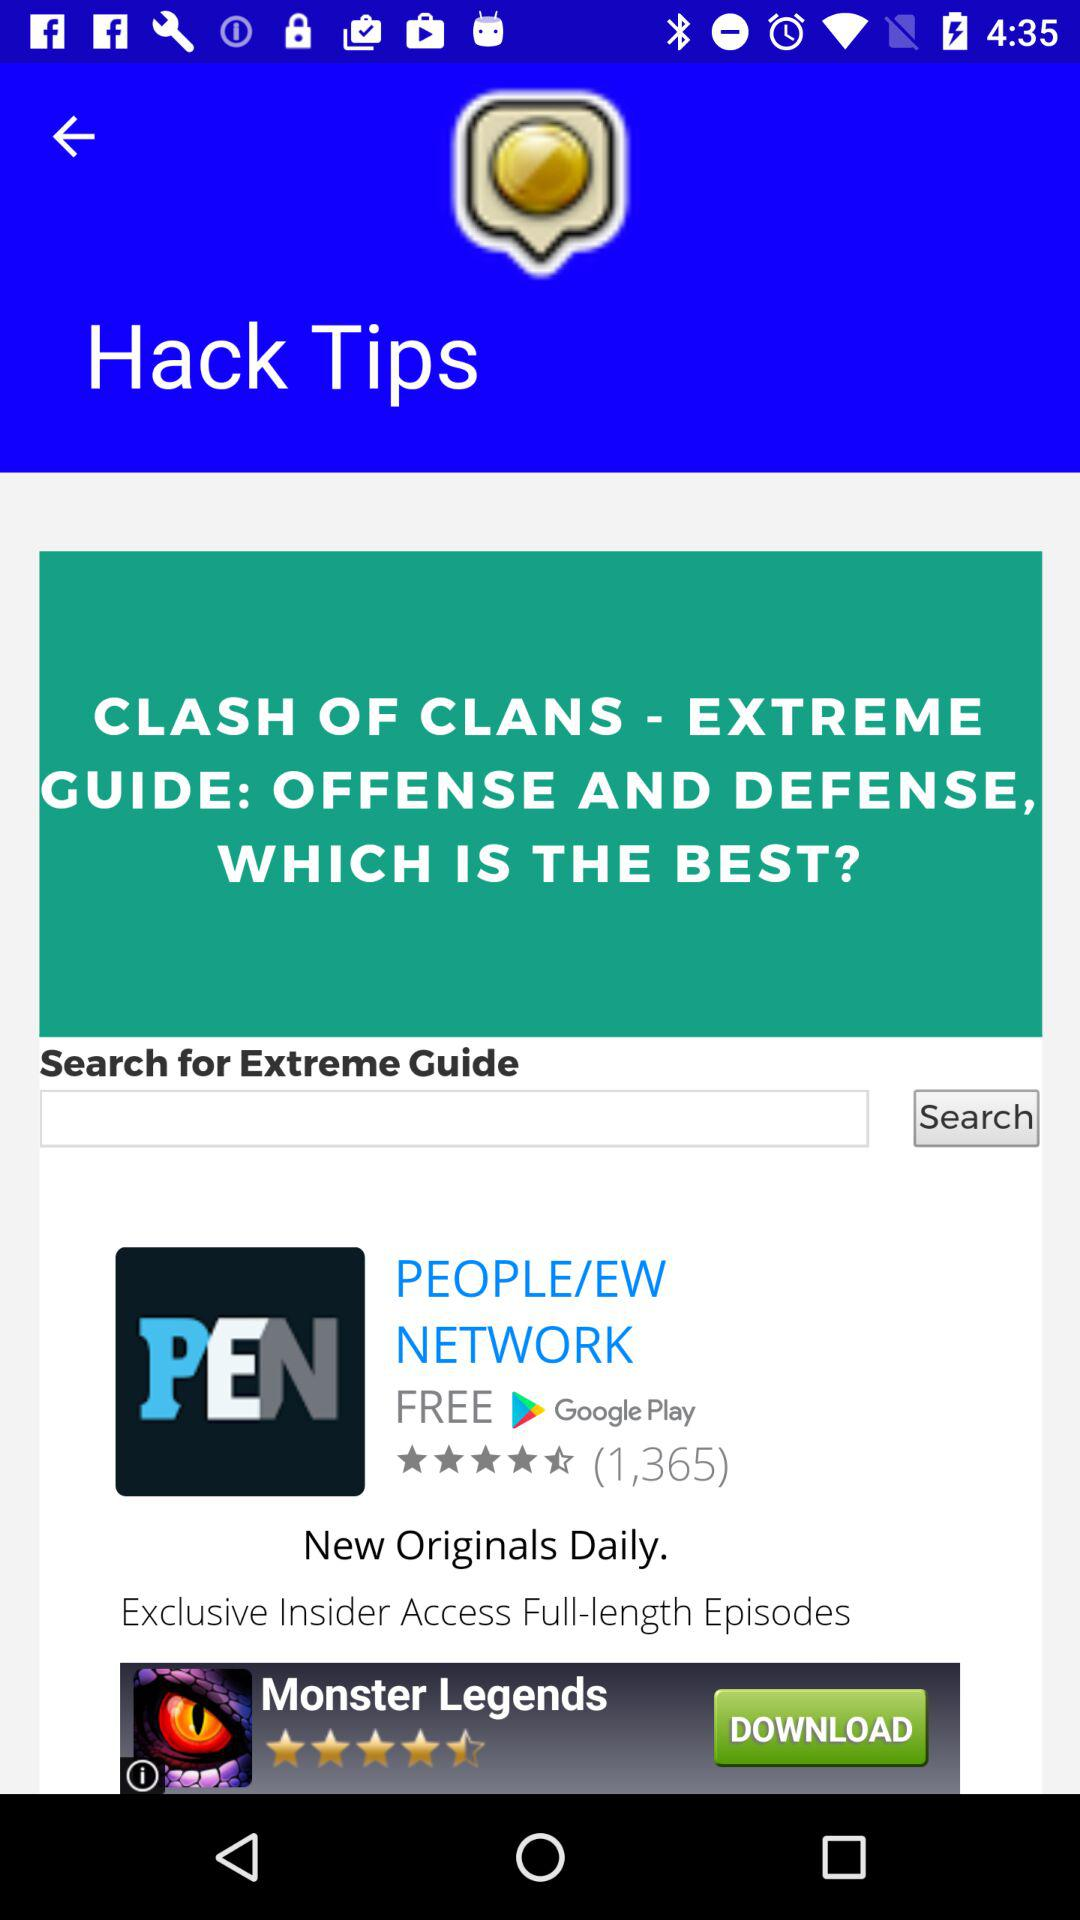How many people have reviewed the "PEN" application? The number of people who have reviewed the "PEN" application is 1,365. 